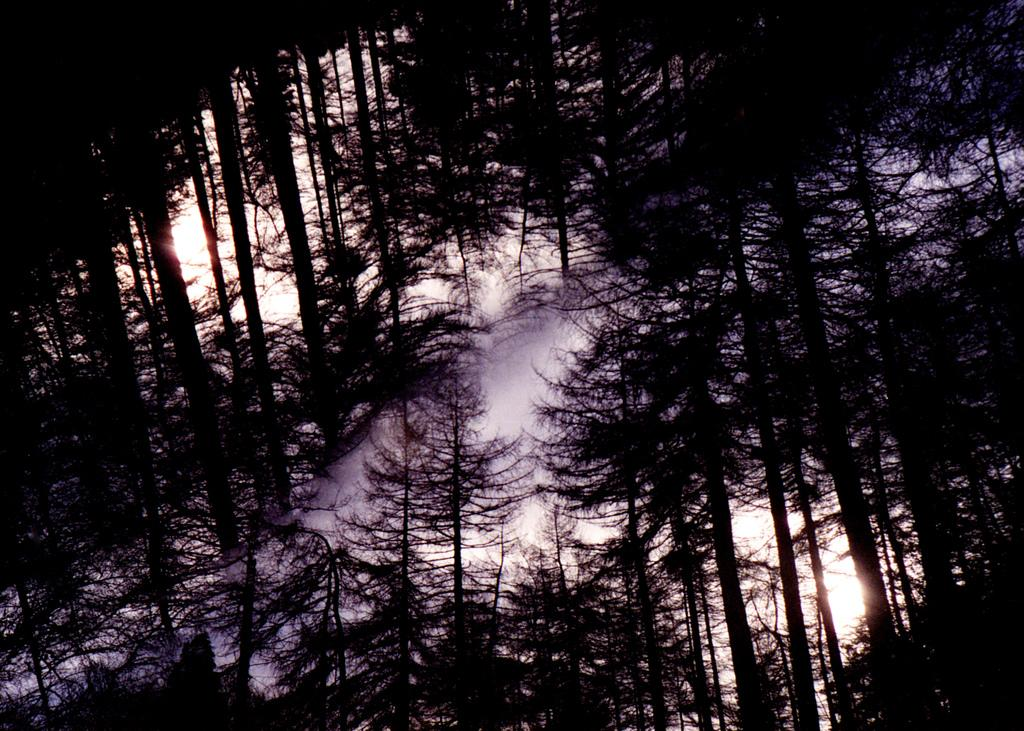What type of vegetation can be seen in the image? There are trees in the image. What part of the natural environment is visible in the image? The sky is visible in the image. Where might this image have been taken, considering the presence of trees? The image may have been taken in a forest, given the presence of trees. What type of sound can be heard coming from the cobweb in the image? There is no cobweb present in the image, and therefore no sound can be heard from it. 